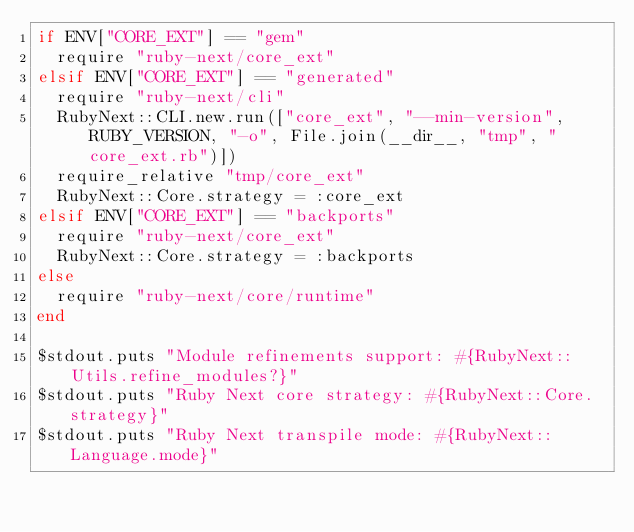<code> <loc_0><loc_0><loc_500><loc_500><_Ruby_>if ENV["CORE_EXT"] == "gem"
  require "ruby-next/core_ext"
elsif ENV["CORE_EXT"] == "generated"
  require "ruby-next/cli"
  RubyNext::CLI.new.run(["core_ext", "--min-version", RUBY_VERSION, "-o", File.join(__dir__, "tmp", "core_ext.rb")])
  require_relative "tmp/core_ext"
  RubyNext::Core.strategy = :core_ext
elsif ENV["CORE_EXT"] == "backports"
  require "ruby-next/core_ext"
  RubyNext::Core.strategy = :backports
else
  require "ruby-next/core/runtime"
end

$stdout.puts "Module refinements support: #{RubyNext::Utils.refine_modules?}"
$stdout.puts "Ruby Next core strategy: #{RubyNext::Core.strategy}"
$stdout.puts "Ruby Next transpile mode: #{RubyNext::Language.mode}"
</code> 